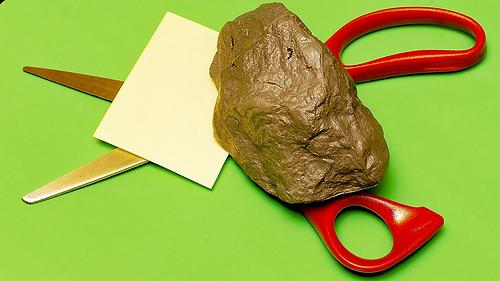Express the image's content in a poetic way. A small grey rock sits upon the Silver Blades, a white paper rests beneath, on a green table that holds this playful fable. How would you describe the rock's surface in the image? Surface of the rock has lines and grooves. List the colors of the scissors handles and describe the material. Red plastic scissor handles. Describe the scissor handles and their features. Long red handle with a large hole for a thumb and smaller hole for a finger. What are the three main items in the image? Rock, paper, and scissors. Identify the three main materials presented in the image. Plastic, metal and paper. What's the appearance of the table's surface in the image? Green surface. Identify the game being referenced in the image. Rock, Paper, Scissors. Is there anything on top of the paper and the scissors? Brown rock is on top of the paper and scissors. Can you find out where the light is reflecting in the image? Light reflecting off of the handle of the scissors. 